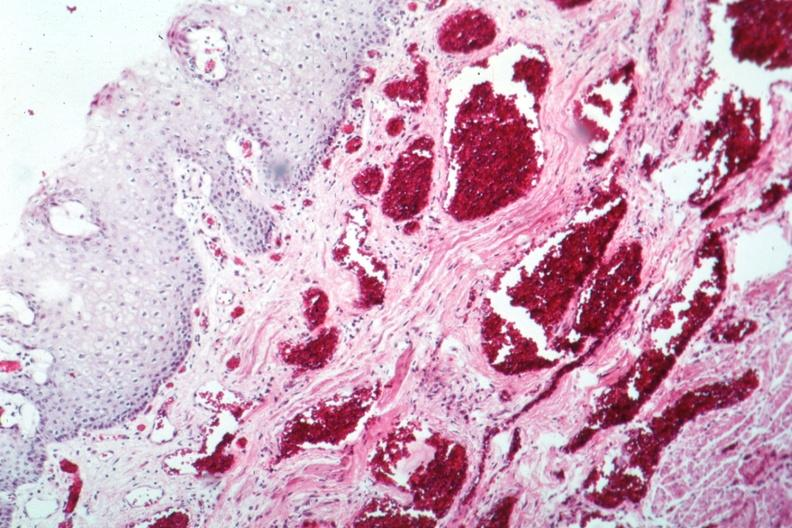does this image show about as good as your can get?
Answer the question using a single word or phrase. Yes 